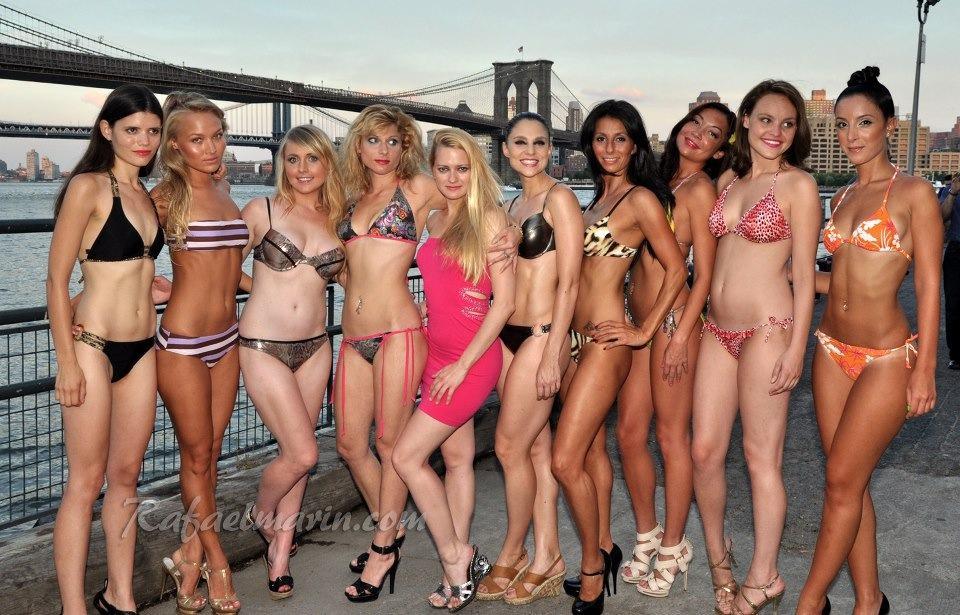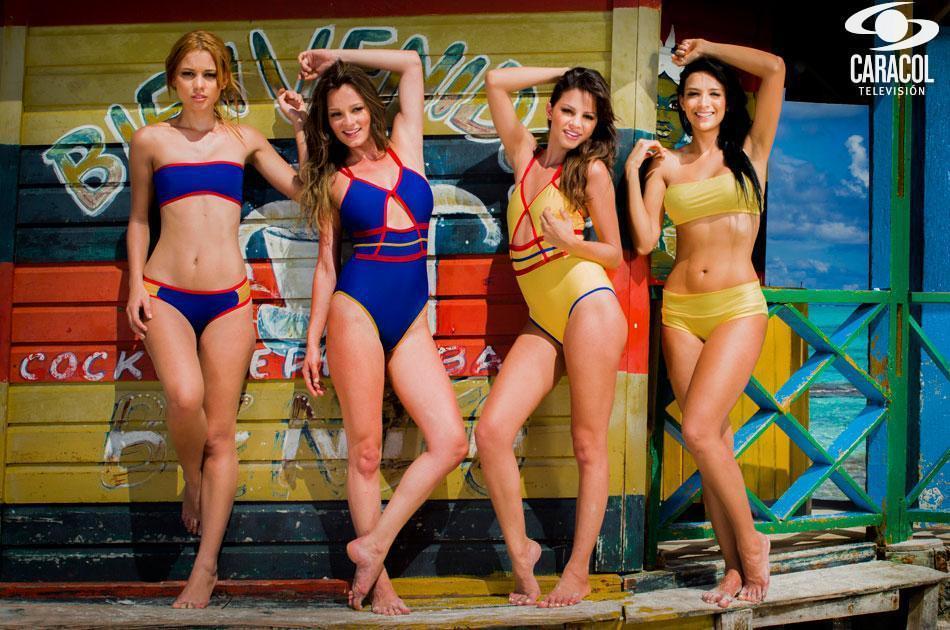The first image is the image on the left, the second image is the image on the right. Assess this claim about the two images: "All bikini models are standing, and no bikini models have their back and rear turned to the camera.". Correct or not? Answer yes or no. Yes. The first image is the image on the left, the second image is the image on the right. Considering the images on both sides, is "One image contains at least 8 women." valid? Answer yes or no. Yes. 